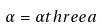Convert formula to latex. <formula><loc_0><loc_0><loc_500><loc_500>\alpha = \alpha t h r e e a</formula> 